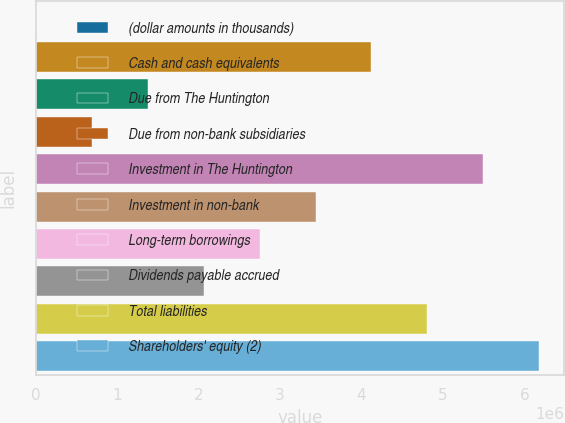Convert chart. <chart><loc_0><loc_0><loc_500><loc_500><bar_chart><fcel>(dollar amounts in thousands)<fcel>Cash and cash equivalents<fcel>Due from The Huntington<fcel>Due from non-bank subsidiaries<fcel>Investment in The Huntington<fcel>Investment in non-bank<fcel>Long-term borrowings<fcel>Dividends payable accrued<fcel>Total liabilities<fcel>Shareholders' equity (2)<nl><fcel>2012<fcel>4.12112e+06<fcel>1.37505e+06<fcel>688530<fcel>5.49415e+06<fcel>3.4346e+06<fcel>2.74808e+06<fcel>2.06157e+06<fcel>4.80764e+06<fcel>6.18067e+06<nl></chart> 